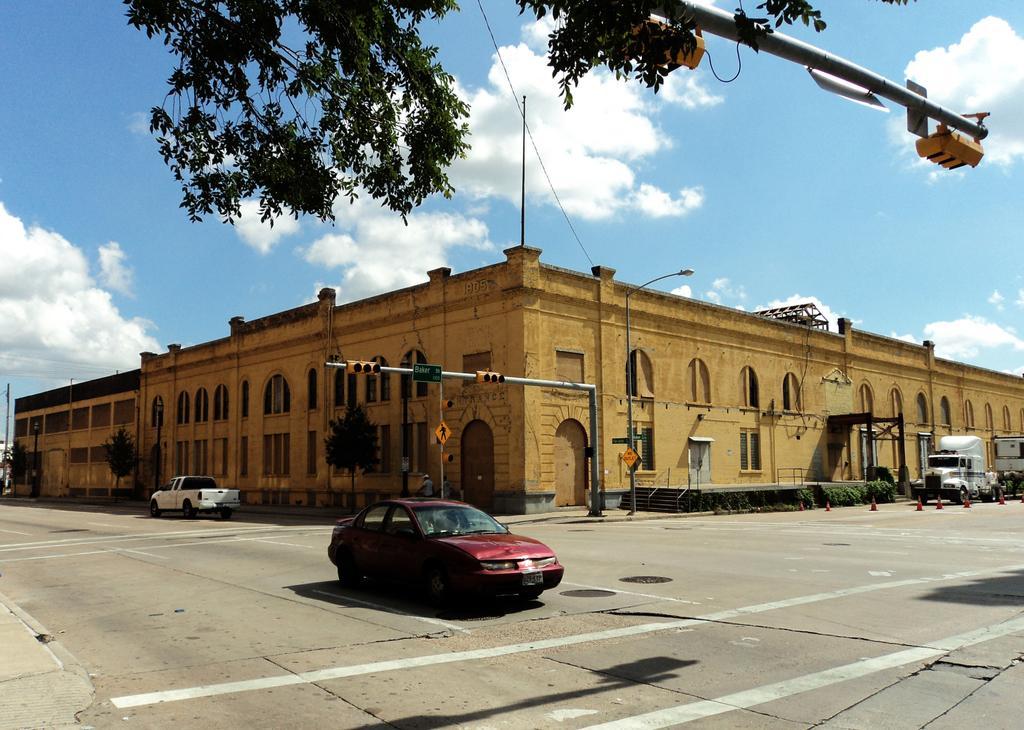How would you summarize this image in a sentence or two? In the image we can see a building and these are the windows of the building. There are even vehicles on the road, this is a road and white lines on the road, these are the road cones and plant. This is a signal pole, light pole and a cloudy sky. 